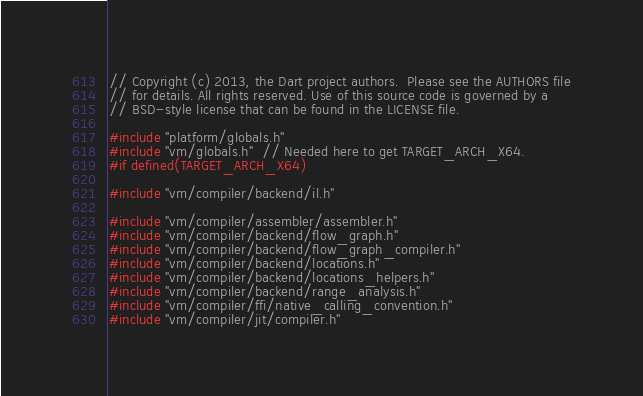Convert code to text. <code><loc_0><loc_0><loc_500><loc_500><_C++_>// Copyright (c) 2013, the Dart project authors.  Please see the AUTHORS file
// for details. All rights reserved. Use of this source code is governed by a
// BSD-style license that can be found in the LICENSE file.

#include "platform/globals.h"
#include "vm/globals.h"  // Needed here to get TARGET_ARCH_X64.
#if defined(TARGET_ARCH_X64)

#include "vm/compiler/backend/il.h"

#include "vm/compiler/assembler/assembler.h"
#include "vm/compiler/backend/flow_graph.h"
#include "vm/compiler/backend/flow_graph_compiler.h"
#include "vm/compiler/backend/locations.h"
#include "vm/compiler/backend/locations_helpers.h"
#include "vm/compiler/backend/range_analysis.h"
#include "vm/compiler/ffi/native_calling_convention.h"
#include "vm/compiler/jit/compiler.h"</code> 